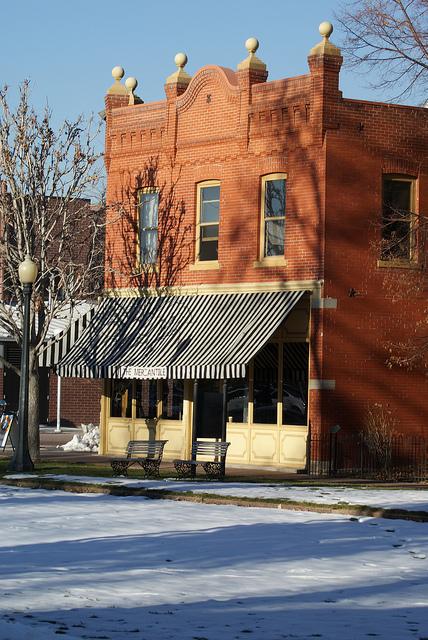The striped awning on the building usually represents what kind of shop?
Quick response, please. Barber shop. Did it snow here?
Write a very short answer. Yes. Where is the awning?
Quick response, please. On building. 